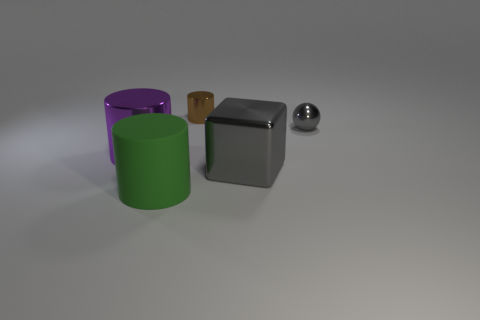Is the number of brown cylinders in front of the block the same as the number of cylinders that are on the left side of the gray sphere?
Keep it short and to the point. No. Does the shiny cylinder in front of the brown cylinder have the same size as the gray shiny thing that is behind the cube?
Your response must be concise. No. What material is the object that is both right of the small brown metal cylinder and in front of the small gray shiny thing?
Provide a succinct answer. Metal. Is the number of big purple things less than the number of cylinders?
Provide a short and direct response. Yes. What is the size of the gray metal object that is behind the big cylinder that is left of the green object?
Your answer should be very brief. Small. The shiny object that is behind the shiny thing that is on the right side of the large shiny block in front of the brown cylinder is what shape?
Make the answer very short. Cylinder. There is another large thing that is made of the same material as the big gray thing; what color is it?
Offer a very short reply. Purple. There is a object on the right side of the big metallic object that is to the right of the cylinder behind the gray metallic sphere; what is its color?
Offer a very short reply. Gray. How many balls are rubber objects or small cyan rubber things?
Offer a terse response. 0. What material is the big object that is the same color as the ball?
Provide a short and direct response. Metal. 